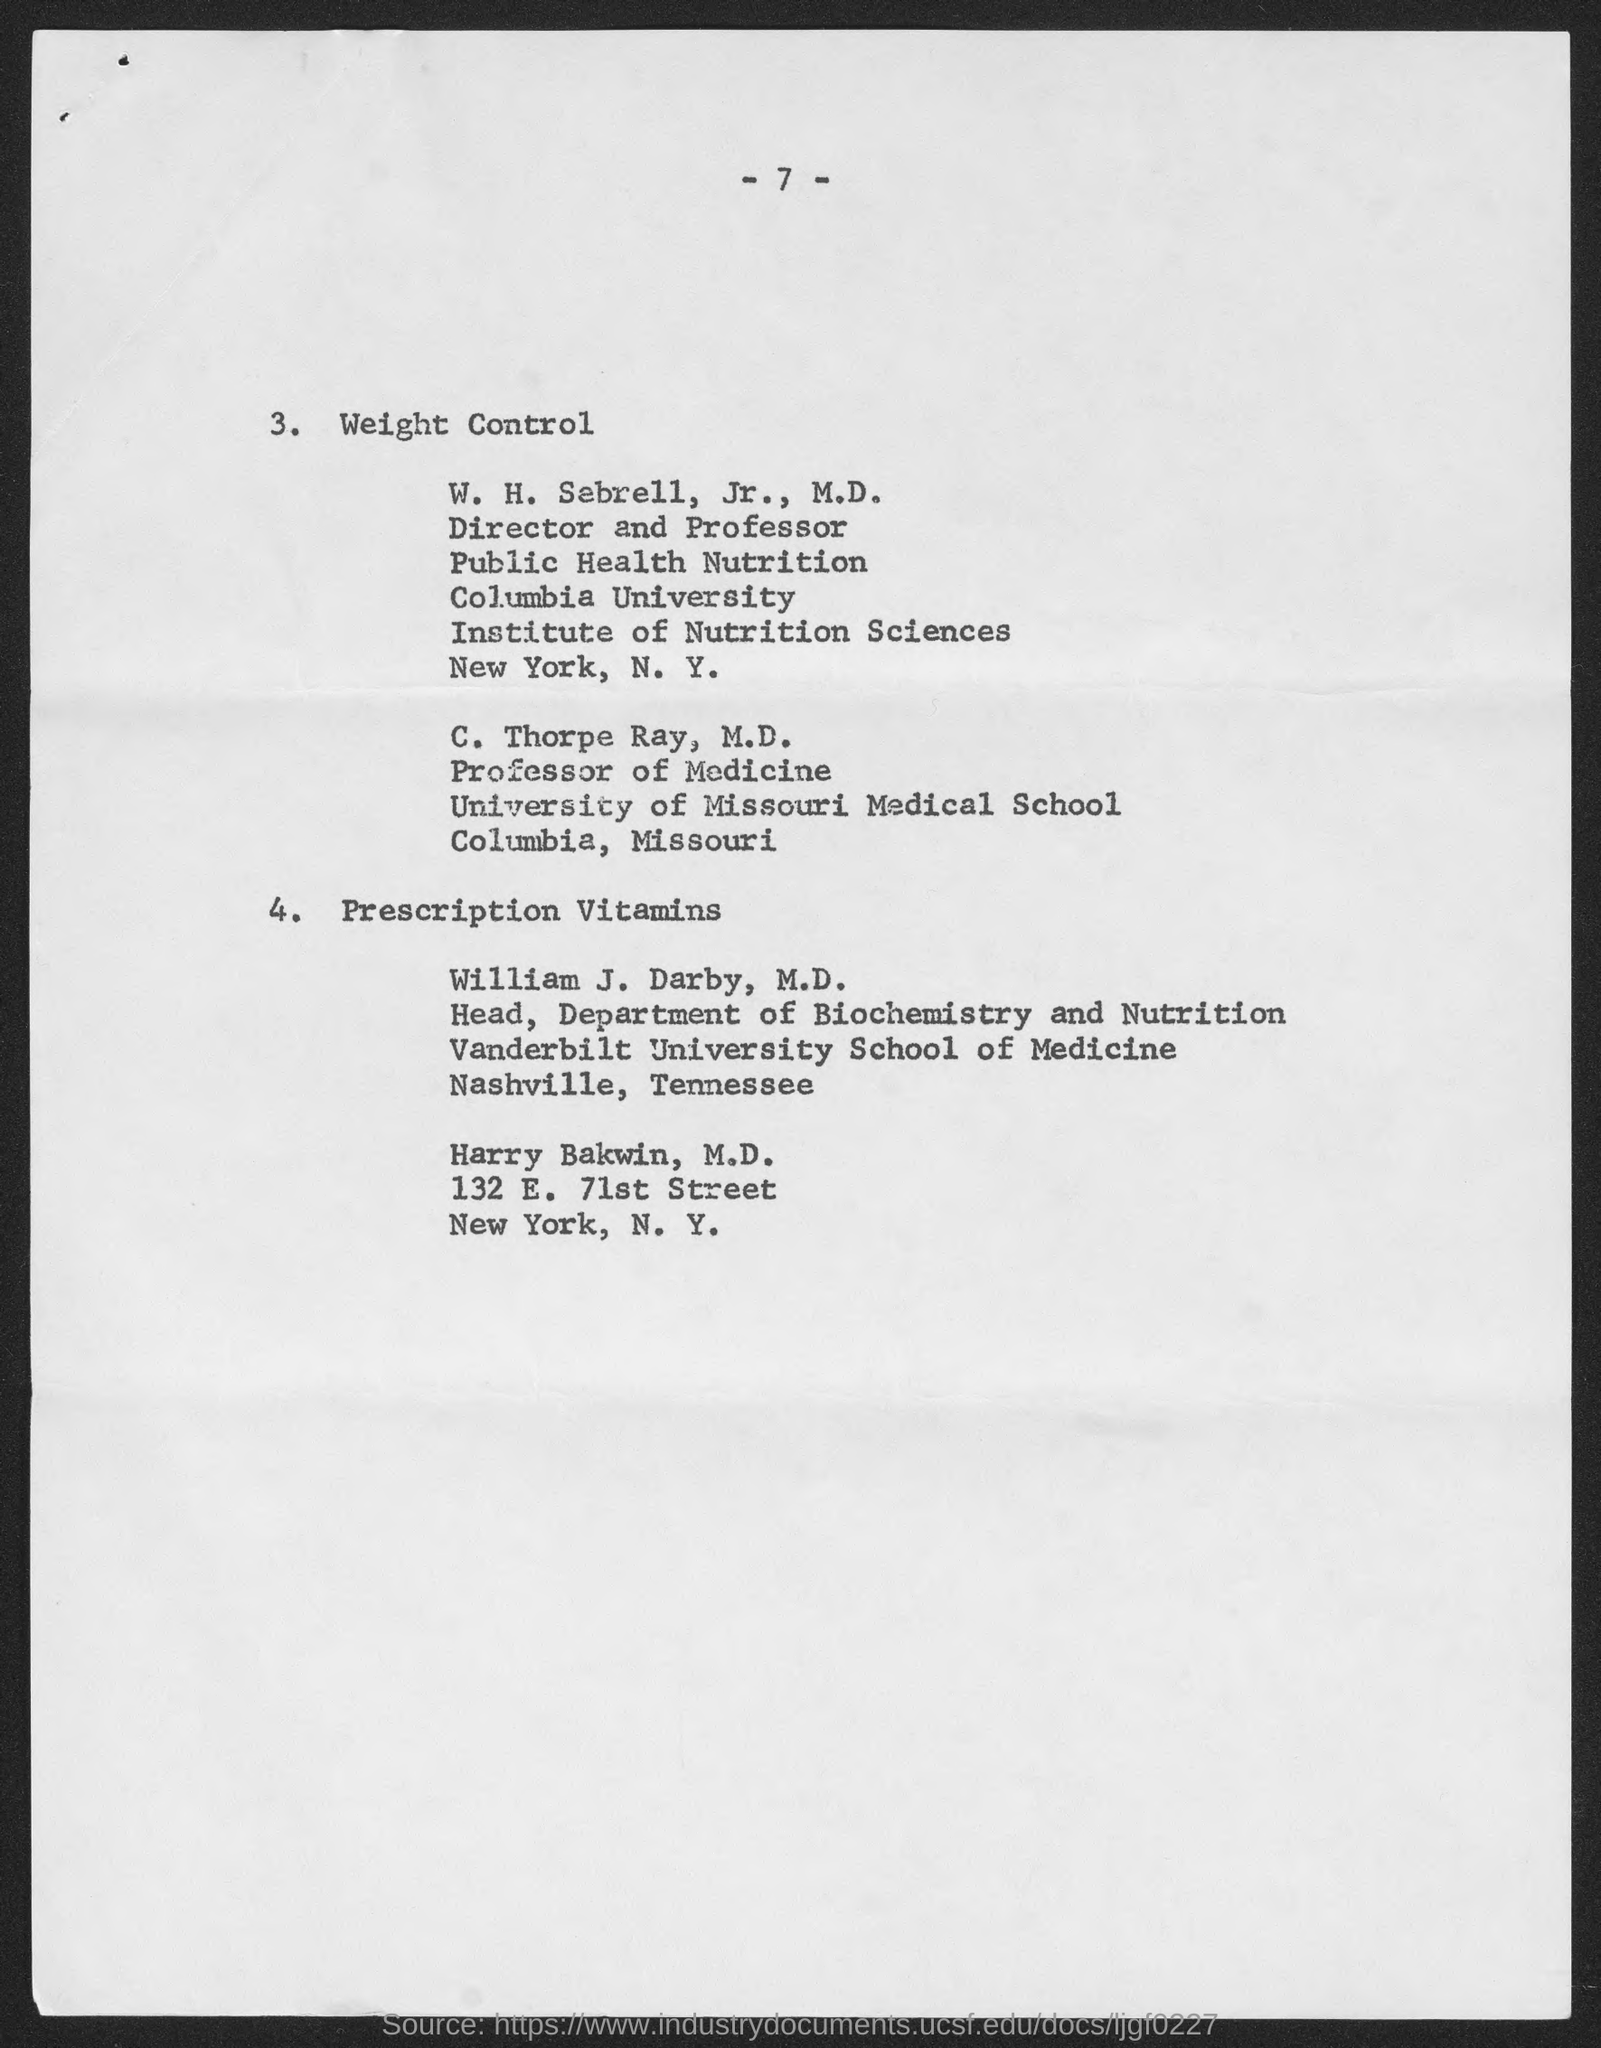What is the page no mentioned in this document?
Your answer should be very brief. -7-. What is the designation of William J. Darby, M.D.?
Ensure brevity in your answer.  Head, Department of Biochemistry and Nutrition. What is the designation of C. Thorpe Ray, M.D.?
Ensure brevity in your answer.  Professor of Medicine. 